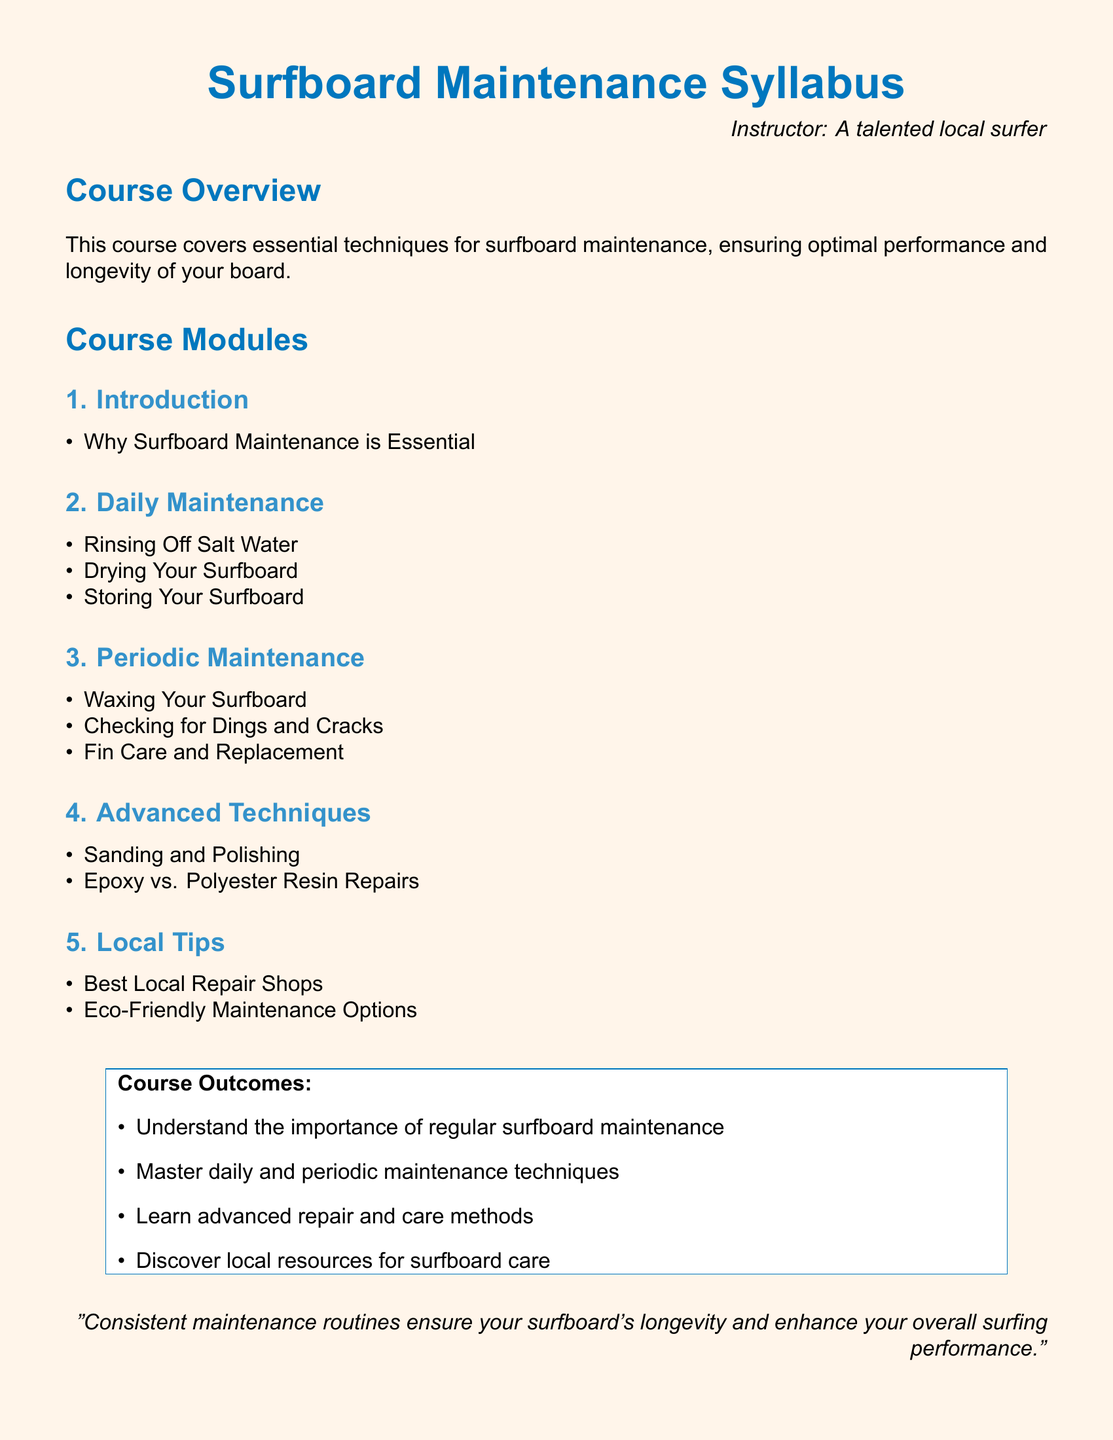what is the main topic of the course? The main topic of the course is essential techniques for surfboard maintenance.
Answer: surfboard maintenance who is the instructor of this course? The syllabus lists the instructor as a talented local surfer.
Answer: a talented local surfer what is one of the objectives of the course? One of the objectives is to master daily and periodic maintenance techniques.
Answer: master daily and periodic maintenance techniques what is covered in the "Advanced Techniques" module? The "Advanced Techniques" module covers sanding and polishing, and epoxy vs. polyester resin repairs.
Answer: sanding and polishing, epoxy vs. polyester resin repairs what is the color of the syllabus background? The background color of the syllabus is a shade of yellow.
Answer: sandy how many sections are there in the course modules? The course has five sections listed under course modules.
Answer: five which type of maintenance involves rinsing off salt water? Rinsing off salt water is part of daily maintenance.
Answer: daily maintenance what does the course outcome mention about resources? The course outcome includes discovering local resources for surfboard care.
Answer: local resources for surfboard care 